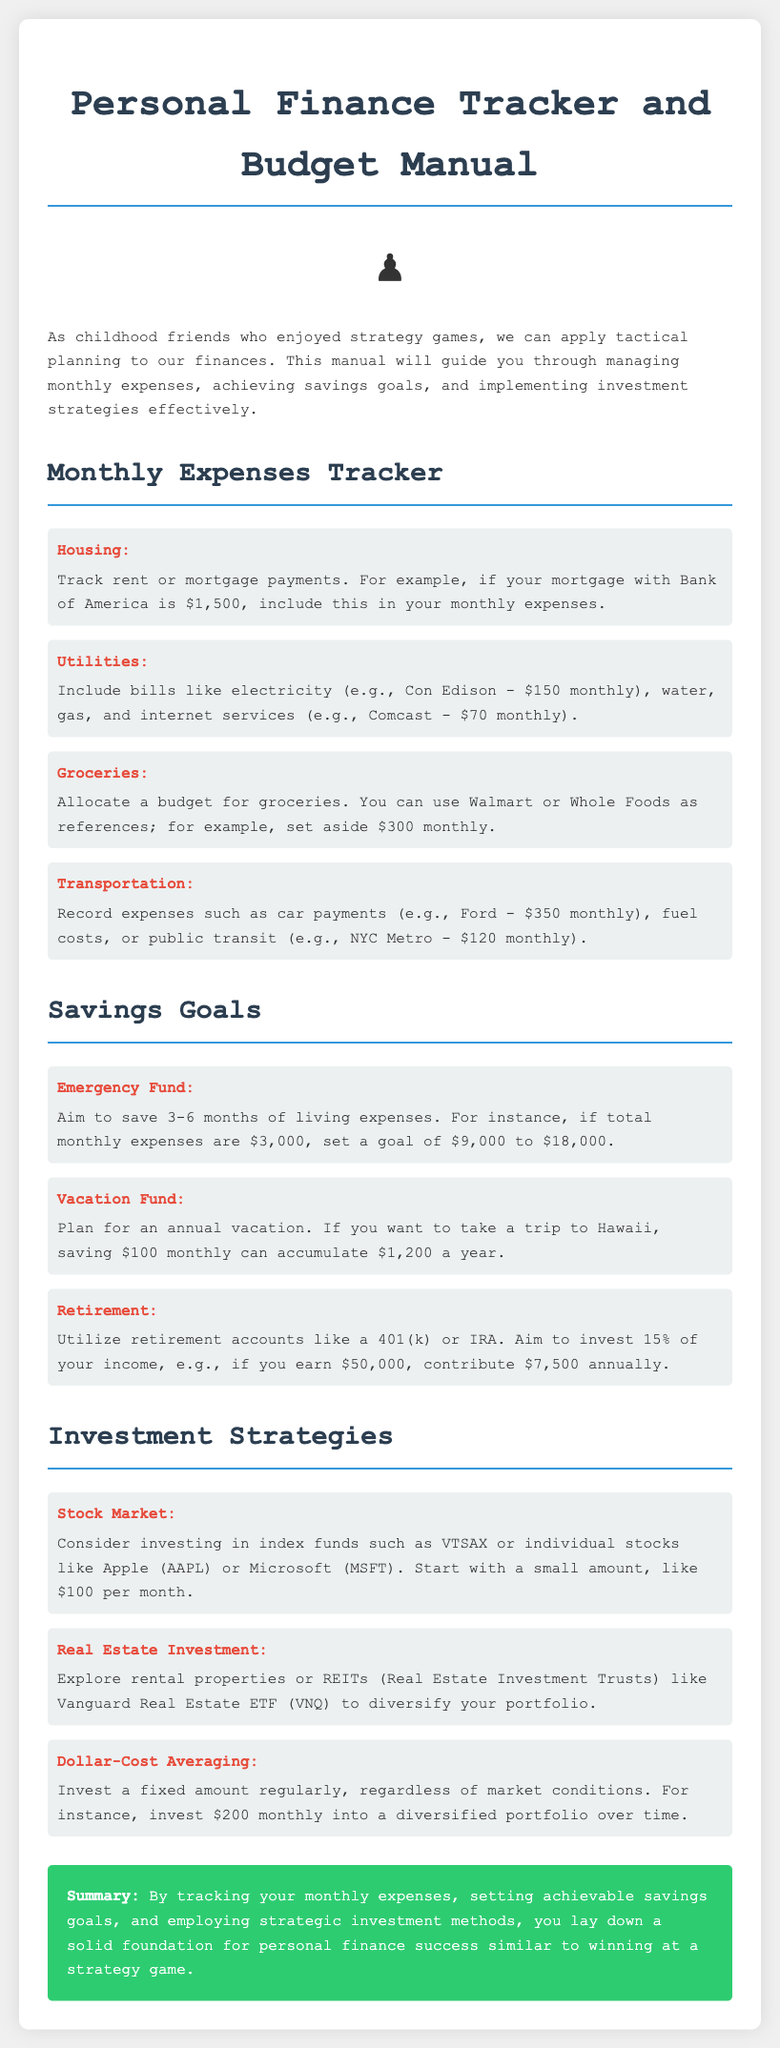What is the monthly cost for rent or mortgage? The document provides an example of a mortgage payment with Bank of America, which is $1,500.
Answer: $1,500 How much should be saved for an emergency fund? According to the document, the goal for an emergency fund should be 3-6 months of living expenses; if total monthly expenses are $3,000, the goal is $9,000 to $18,000.
Answer: $9,000 to $18,000 What is the suggested monthly savings for a vacation fund? The document suggests saving $100 monthly to accumulate $1,200 for an annual vacation.
Answer: $100 Which retirement accounts are mentioned? The document references retirement accounts such as a 401(k) or IRA for savings goals.
Answer: 401(k) or IRA How much should be contributed annually if you earn $50,000? The document states to aim to invest 15% of income if earning $50,000, which amounts to $7,500 annually.
Answer: $7,500 What is the name of one suggested index fund? The document mentions VTSAX as a suggested index fund for investment strategies.
Answer: VTSAX What is one strategy for investing regularly mentioned in the document? The document refers to dollar-cost averaging as a strategy where a fixed amount is invested regularly.
Answer: Dollar-Cost Averaging What is the purpose of tracking monthly expenses? The document states that tracking monthly expenses helps lay down a solid foundation for personal finance success.
Answer: Solid foundation What is the monthly expense for groceries suggested in the document? The document suggests setting aside $300 monthly for groceries.
Answer: $300 